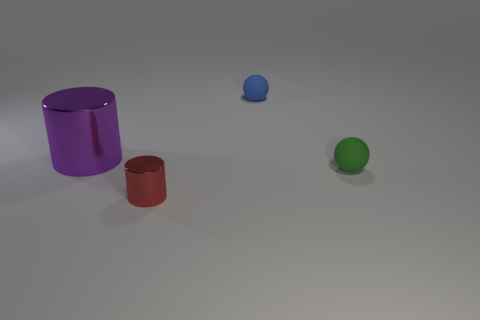Add 1 tiny blue balls. How many objects exist? 5 Subtract 0 purple balls. How many objects are left? 4 Subtract all purple metal cylinders. Subtract all tiny blue metal cubes. How many objects are left? 3 Add 3 green things. How many green things are left? 4 Add 1 large cyan shiny objects. How many large cyan shiny objects exist? 1 